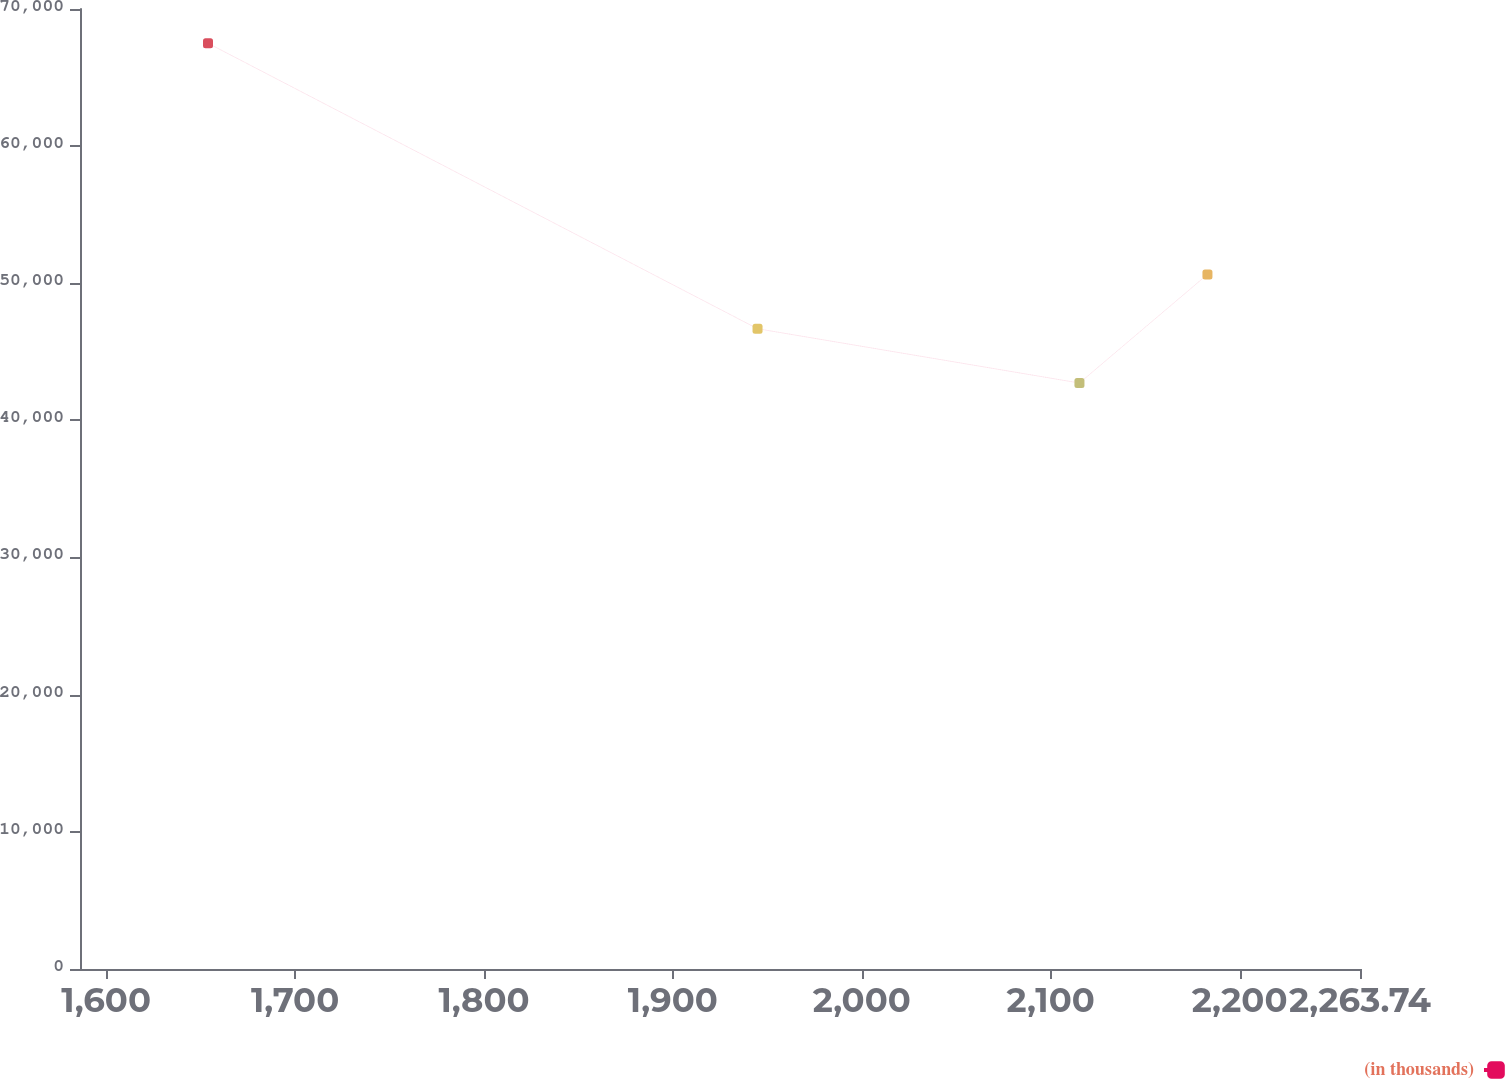Convert chart. <chart><loc_0><loc_0><loc_500><loc_500><line_chart><ecel><fcel>(in thousands)<nl><fcel>1653.9<fcel>67503.5<nl><fcel>1944.81<fcel>46686.5<nl><fcel>2115.22<fcel>42728.3<nl><fcel>2182.98<fcel>50644.7<nl><fcel>2331.5<fcel>27921.5<nl></chart> 